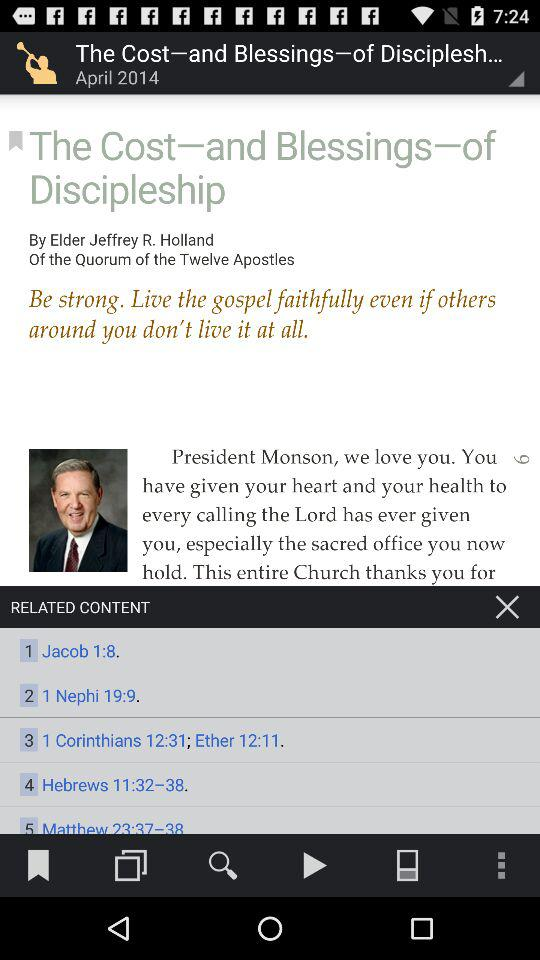Who's the author of "The Cost—and Blessings—of Discipleship"? The author of "The Cost—and Blessings—of Discipleship" is Elder Jeffrey R. Holland. 